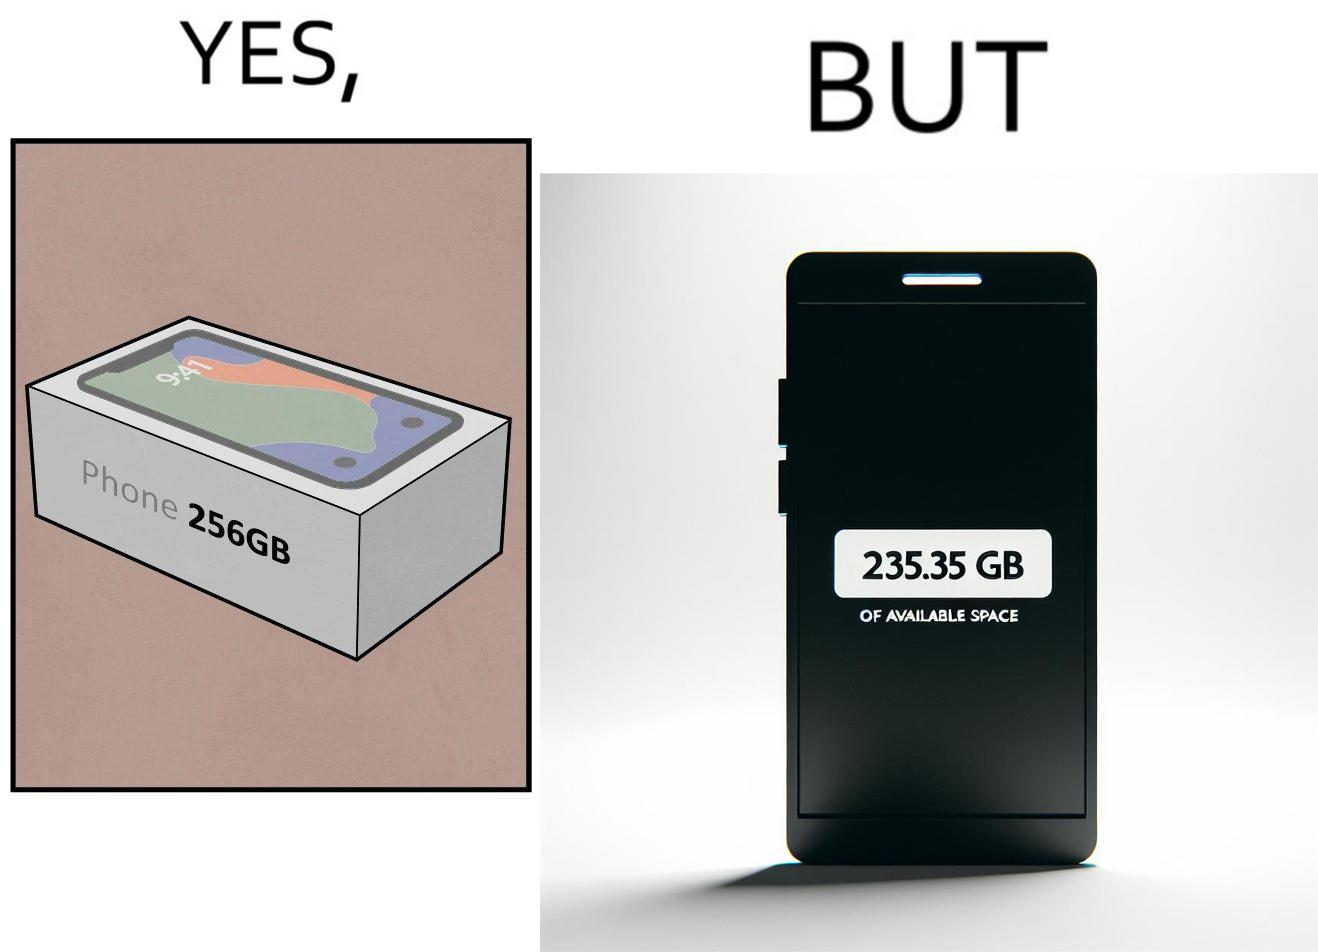Describe the content of this image. The images are funny since they show how smartphone manufacturers advertise their smartphones to have a high internal storage space but in reality, the amount of space available to an user is considerably less due to pre-installed software 